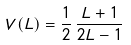Convert formula to latex. <formula><loc_0><loc_0><loc_500><loc_500>V ( L ) = \frac { 1 } { 2 } \, \frac { L + 1 } { 2 L - 1 }</formula> 